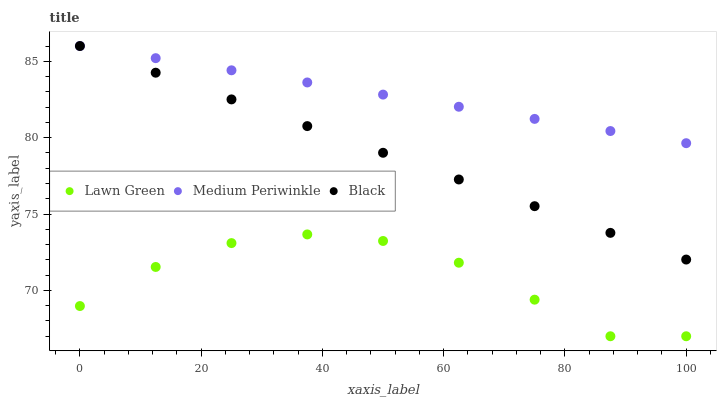Does Lawn Green have the minimum area under the curve?
Answer yes or no. Yes. Does Medium Periwinkle have the maximum area under the curve?
Answer yes or no. Yes. Does Black have the minimum area under the curve?
Answer yes or no. No. Does Black have the maximum area under the curve?
Answer yes or no. No. Is Medium Periwinkle the smoothest?
Answer yes or no. Yes. Is Lawn Green the roughest?
Answer yes or no. Yes. Is Black the smoothest?
Answer yes or no. No. Is Black the roughest?
Answer yes or no. No. Does Lawn Green have the lowest value?
Answer yes or no. Yes. Does Black have the lowest value?
Answer yes or no. No. Does Black have the highest value?
Answer yes or no. Yes. Is Lawn Green less than Medium Periwinkle?
Answer yes or no. Yes. Is Medium Periwinkle greater than Lawn Green?
Answer yes or no. Yes. Does Medium Periwinkle intersect Black?
Answer yes or no. Yes. Is Medium Periwinkle less than Black?
Answer yes or no. No. Is Medium Periwinkle greater than Black?
Answer yes or no. No. Does Lawn Green intersect Medium Periwinkle?
Answer yes or no. No. 